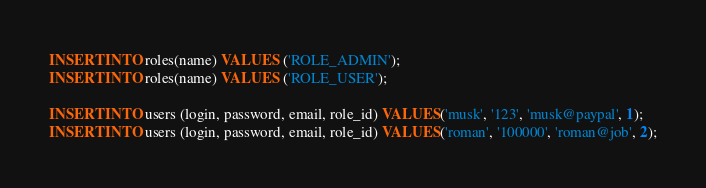Convert code to text. <code><loc_0><loc_0><loc_500><loc_500><_SQL_>INSERT INTO roles(name) VALUES ('ROLE_ADMIN');
INSERT INTO roles(name) VALUES ('ROLE_USER');

INSERT INTO users (login, password, email, role_id) VALUES('musk', '123', 'musk@paypal', 1);
INSERT INTO users (login, password, email, role_id) VALUES('roman', '100000', 'roman@job', 2);



</code> 